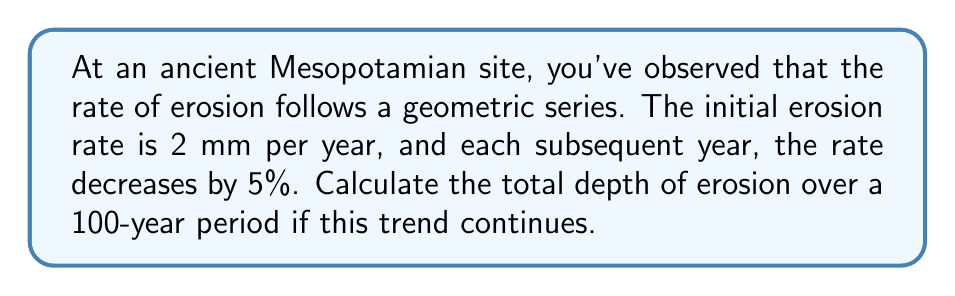Help me with this question. To solve this problem, we need to use the formula for the sum of a geometric series:

$$S_n = \frac{a(1-r^n)}{1-r}$$

Where:
$S_n$ is the sum of the series
$a$ is the first term
$r$ is the common ratio
$n$ is the number of terms

Step 1: Identify the components of our series
$a = 2$ (initial rate of 2 mm per year)
$r = 0.95$ (5% decrease each year, so 95% of the previous year)
$n = 100$ (100-year period)

Step 2: Plug these values into the formula

$$S_{100} = \frac{2(1-0.95^{100})}{1-0.95}$$

Step 3: Simplify the numerator
$0.95^{100} \approx 0.00592$ (using a calculator)

$$S_{100} = \frac{2(1-0.00592)}{0.05} = \frac{2(0.99408)}{0.05}$$

Step 4: Calculate the final result

$$S_{100} = \frac{1.98816}{0.05} = 39.7632$$

Therefore, the total depth of erosion over 100 years is approximately 39.76 mm.
Answer: 39.76 mm 